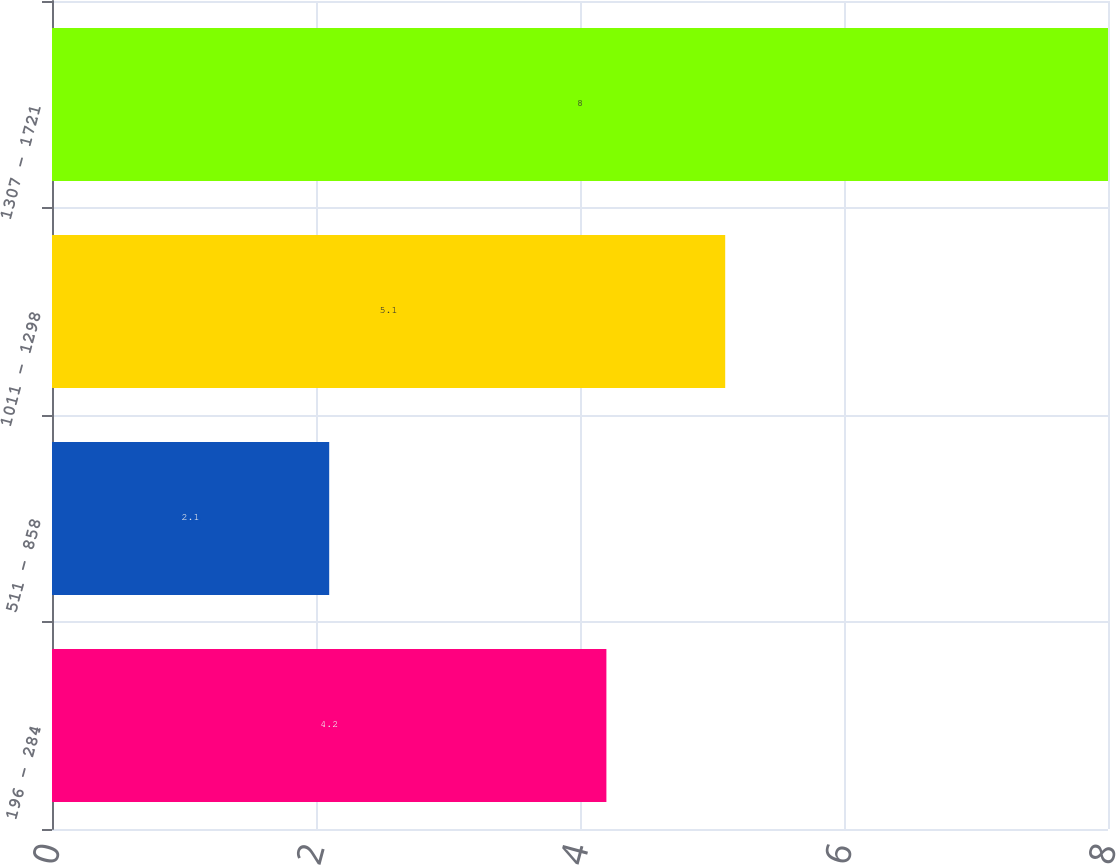Convert chart to OTSL. <chart><loc_0><loc_0><loc_500><loc_500><bar_chart><fcel>196 - 284<fcel>511 - 858<fcel>1011 - 1298<fcel>1307 - 1721<nl><fcel>4.2<fcel>2.1<fcel>5.1<fcel>8<nl></chart> 